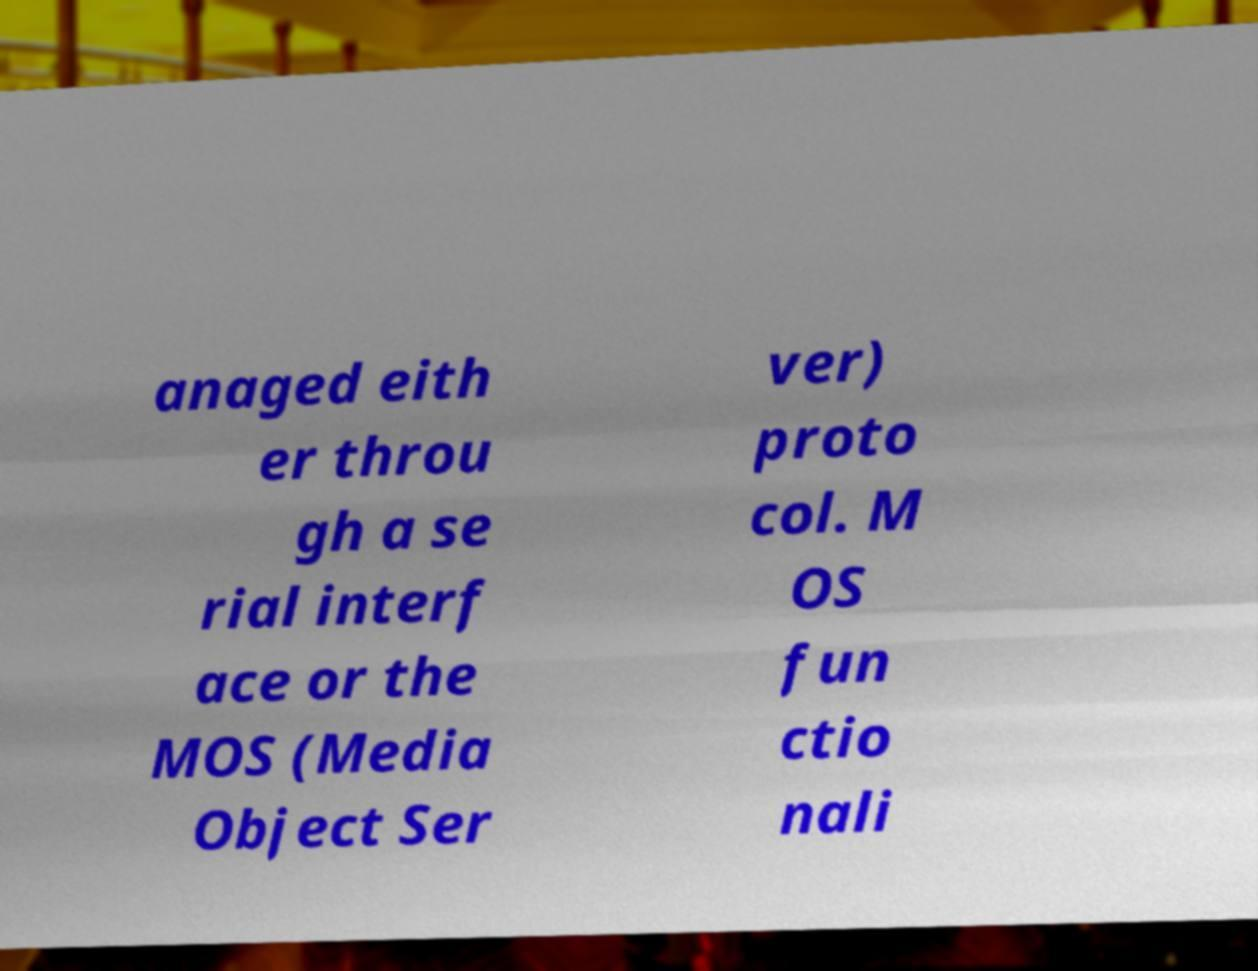I need the written content from this picture converted into text. Can you do that? anaged eith er throu gh a se rial interf ace or the MOS (Media Object Ser ver) proto col. M OS fun ctio nali 